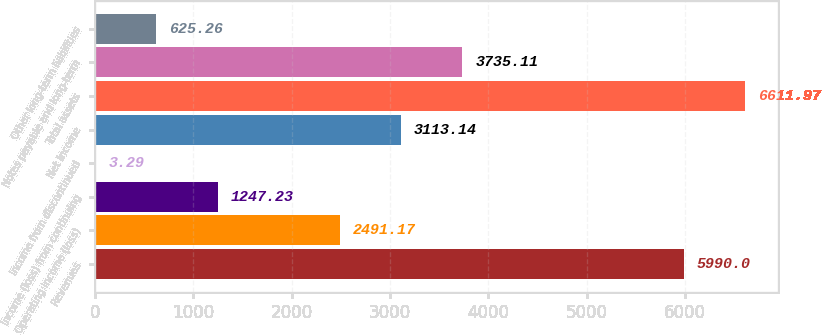Convert chart to OTSL. <chart><loc_0><loc_0><loc_500><loc_500><bar_chart><fcel>Revenues<fcel>Operating income (loss)<fcel>Income (loss) from continuing<fcel>Income from discontinued<fcel>Net income<fcel>Total assets<fcel>Notes payable and long-term<fcel>Other long-term liabilities<nl><fcel>5990<fcel>2491.17<fcel>1247.23<fcel>3.29<fcel>3113.14<fcel>6611.97<fcel>3735.11<fcel>625.26<nl></chart> 